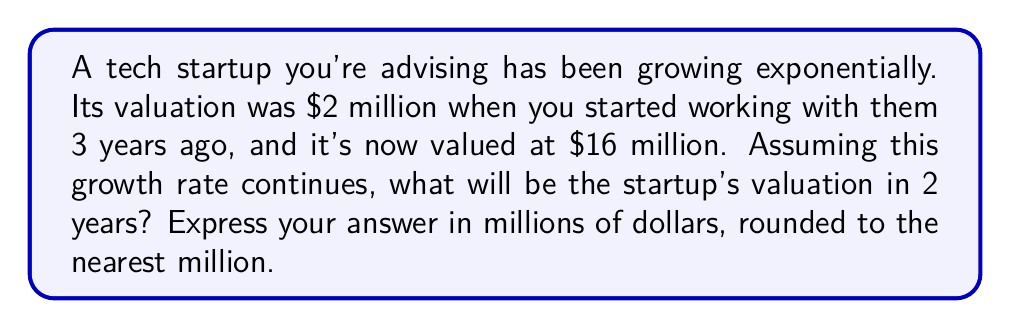Solve this math problem. Let's approach this step-by-step:

1) We can model this situation using the exponential growth formula:
   
   $A = P(1 + r)^t$

   Where:
   $A$ is the final amount
   $P$ is the initial principal
   $r$ is the annual growth rate
   $t$ is the time in years

2) We know:
   $P = 2$ million (initial valuation)
   $A = 16$ million (current valuation after 3 years)
   $t = 3$ years

3) Let's substitute these into our formula:

   $16 = 2(1 + r)^3$

4) Solve for $r$:

   $8 = (1 + r)^3$
   $2 = 1 + r$
   $r = 1$ or 100%

5) Now that we know the annual growth rate, we can predict the valuation in 2 more years:

   $A = 16(1 + 1)^2$
   $A = 16(2)^2$
   $A = 16(4)$
   $A = 64$

Therefore, in 2 years, the startup's valuation will be $64 million.
Answer: $64 million 